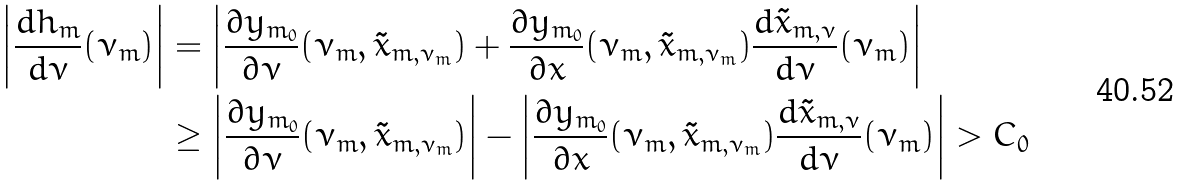<formula> <loc_0><loc_0><loc_500><loc_500>\left | \frac { d h _ { m } } { d \nu } ( \nu _ { m } ) \right | & = \left | \frac { \partial y _ { m _ { 0 } } } { \partial \nu } ( \nu _ { m } , \tilde { x } _ { m , \nu _ { m } } ) + \frac { \partial y _ { m _ { 0 } } } { \partial x } ( \nu _ { m } , \tilde { x } _ { m , \nu _ { m } } ) \frac { d \tilde { x } _ { m , \nu } } { d \nu } ( \nu _ { m } ) \right | \\ & \geq \left | \frac { \partial y _ { m _ { 0 } } } { \partial \nu } ( \nu _ { m } , \tilde { x } _ { m , \nu _ { m } } ) \right | - \left | \frac { \partial y _ { m _ { 0 } } } { \partial x } ( \nu _ { m } , \tilde { x } _ { m , \nu _ { m } } ) \frac { d \tilde { x } _ { m , \nu } } { d \nu } ( \nu _ { m } ) \right | > C _ { 0 }</formula> 